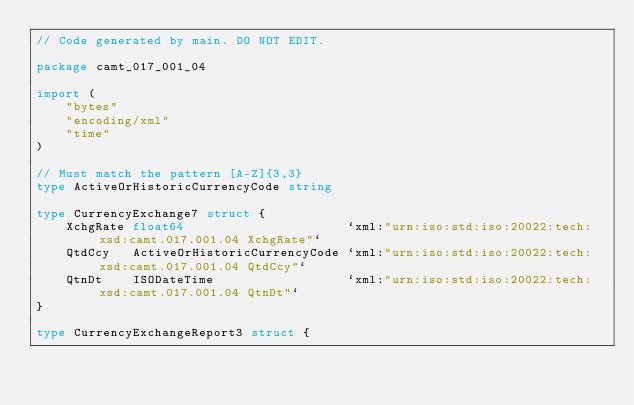<code> <loc_0><loc_0><loc_500><loc_500><_Go_>// Code generated by main. DO NOT EDIT.

package camt_017_001_04

import (
	"bytes"
	"encoding/xml"
	"time"
)

// Must match the pattern [A-Z]{3,3}
type ActiveOrHistoricCurrencyCode string

type CurrencyExchange7 struct {
	XchgRate float64                      `xml:"urn:iso:std:iso:20022:tech:xsd:camt.017.001.04 XchgRate"`
	QtdCcy   ActiveOrHistoricCurrencyCode `xml:"urn:iso:std:iso:20022:tech:xsd:camt.017.001.04 QtdCcy"`
	QtnDt    ISODateTime                  `xml:"urn:iso:std:iso:20022:tech:xsd:camt.017.001.04 QtnDt"`
}

type CurrencyExchangeReport3 struct {</code> 